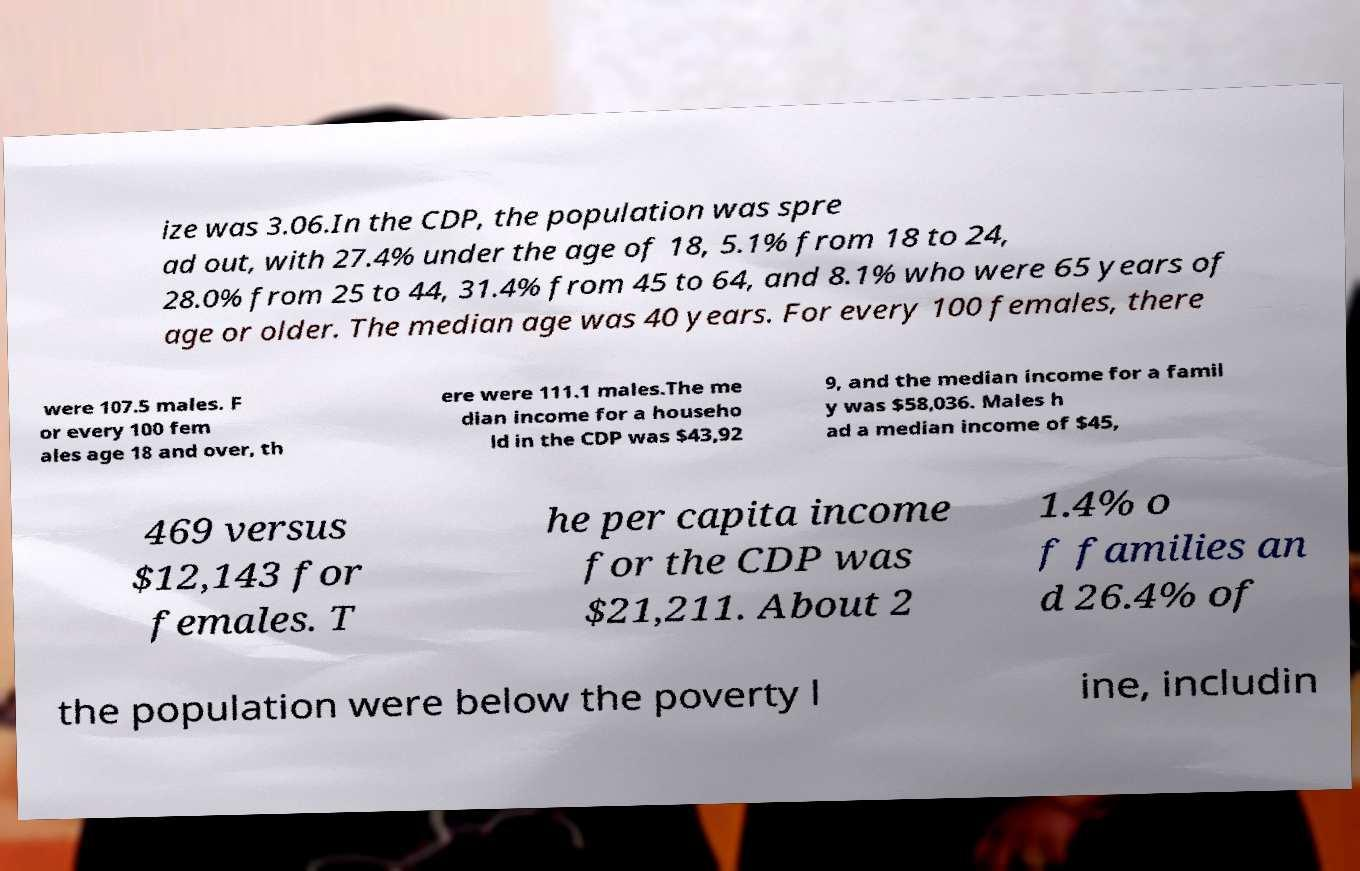Can you accurately transcribe the text from the provided image for me? ize was 3.06.In the CDP, the population was spre ad out, with 27.4% under the age of 18, 5.1% from 18 to 24, 28.0% from 25 to 44, 31.4% from 45 to 64, and 8.1% who were 65 years of age or older. The median age was 40 years. For every 100 females, there were 107.5 males. F or every 100 fem ales age 18 and over, th ere were 111.1 males.The me dian income for a househo ld in the CDP was $43,92 9, and the median income for a famil y was $58,036. Males h ad a median income of $45, 469 versus $12,143 for females. T he per capita income for the CDP was $21,211. About 2 1.4% o f families an d 26.4% of the population were below the poverty l ine, includin 